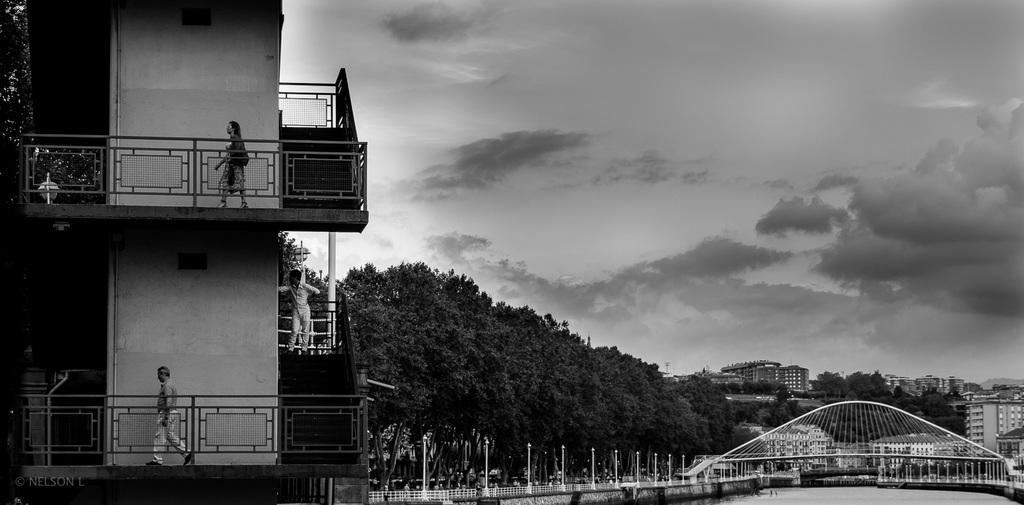In one or two sentences, can you explain what this image depicts? It is a black and white image. In this image on the left side there is a building and people are walking in the building. At the center of the image there is water and we can see a bridge. Beside the bridge there are lights and a metal fence. In the background of the image there are trees, buildings and sky. 